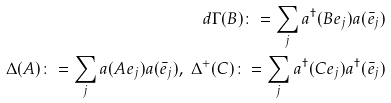Convert formula to latex. <formula><loc_0><loc_0><loc_500><loc_500>d \Gamma ( B ) \colon = \sum _ { j } a ^ { \dagger } ( B e _ { j } ) a ( \bar { e } _ { j } ) \\ \Delta ( A ) \colon = \sum _ { j } a ( A e _ { j } ) a ( \bar { e } _ { j } ) , \ \Delta ^ { + } ( C ) \colon = \sum _ { j } a ^ { \dagger } ( C e _ { j } ) a ^ { \dagger } ( \bar { e } _ { j } )</formula> 